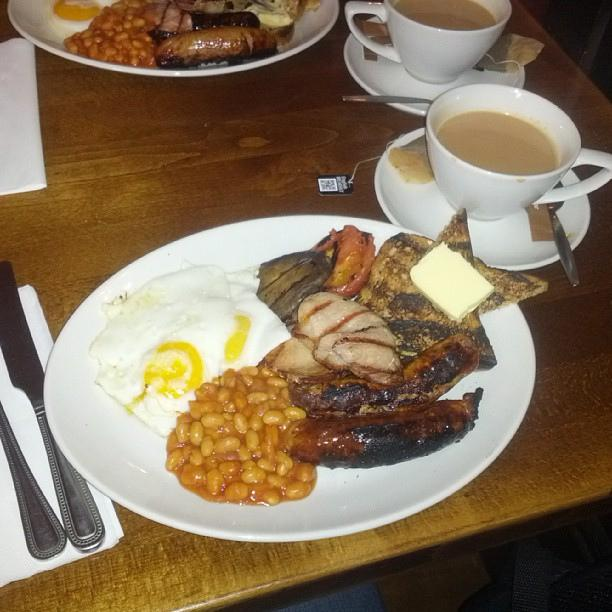What is the side dish on the plate? Please explain your reasoning. beans. The dish has beans. 